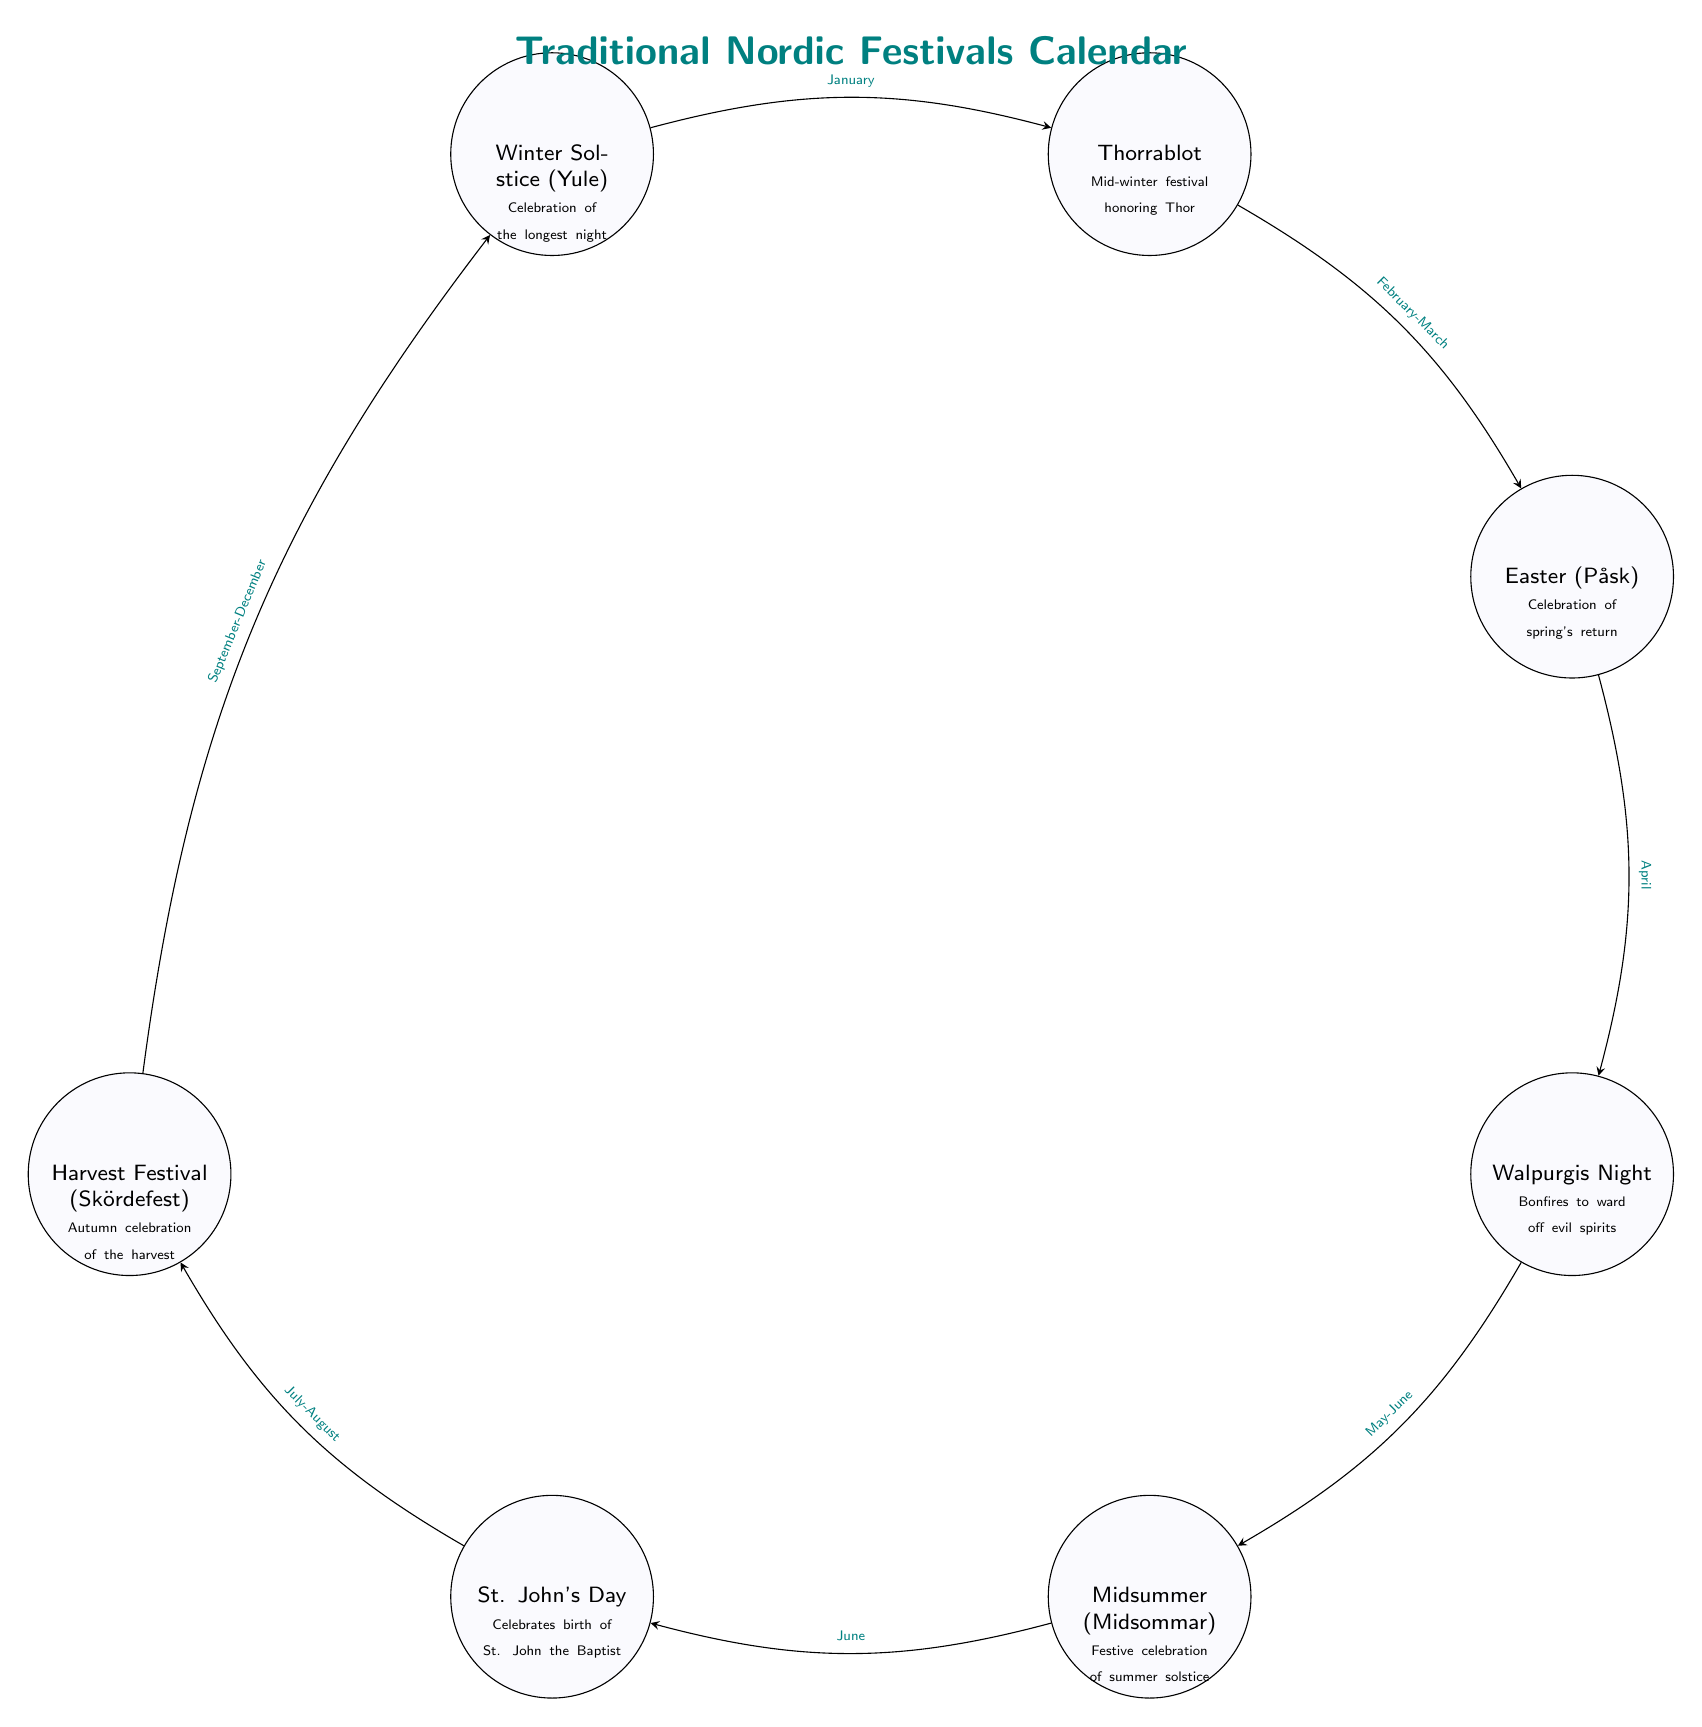What is the first festival listed in the calendar? The diagram starts with the Winter Solstice (Yule) as the first node on the top.
Answer: Winter Solstice (Yule) How many festivals are shown in the diagram? By counting the individual nodes listed, we see there are a total of seven festivals.
Answer: 7 What month is Thorrablot celebrated? The edge leading from the Winter Solstice to Thorrablot indicates the month of January.
Answer: January What festival occurs right after Easter? According to the flow from Easter, the next festival is Walpurgis Night, indicated in the diagram.
Answer: Walpurgis Night Which festival is connected to Midsummer? Tracing the path from Midsummer in the diagram leads to St. John's Day, which is the festival that follows.
Answer: St. John's Day What is the ritual associated with the Winter Solstice? The diagram notes that the ritual for Winter Solstice (Yule) is a celebration of the longest night, as indicated in the node.
Answer: Celebration of the longest night During which season is the Harvest Festival celebrated? Following the diagram, the Harvest Festival occurs during autumn, specifically between September and December.
Answer: Autumn What is the relationship between Walpurgis and Midsummer? The flow of the diagram connects Walpurgis to Midsummer, indicating that Midsummer occurs next after Walpurgis, specifically in May-June.
Answer: Midsummer occurs after Walpurgis What color is used for the nodes representing festivals? The nodes representing the festivals in the diagram are filled with lavender color, as indicated by the specified style.
Answer: Lavender 